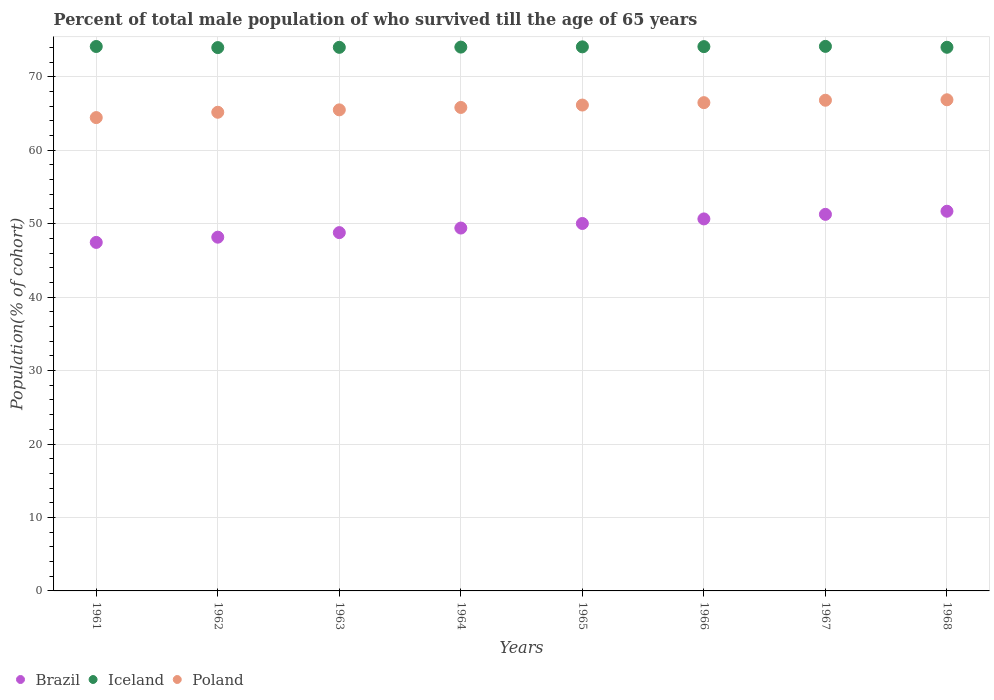What is the percentage of total male population who survived till the age of 65 years in Iceland in 1968?
Offer a very short reply. 74.02. Across all years, what is the maximum percentage of total male population who survived till the age of 65 years in Brazil?
Ensure brevity in your answer.  51.69. Across all years, what is the minimum percentage of total male population who survived till the age of 65 years in Poland?
Make the answer very short. 64.44. In which year was the percentage of total male population who survived till the age of 65 years in Iceland maximum?
Make the answer very short. 1967. In which year was the percentage of total male population who survived till the age of 65 years in Poland minimum?
Offer a very short reply. 1961. What is the total percentage of total male population who survived till the age of 65 years in Iceland in the graph?
Offer a terse response. 592.49. What is the difference between the percentage of total male population who survived till the age of 65 years in Poland in 1964 and that in 1965?
Your answer should be compact. -0.33. What is the difference between the percentage of total male population who survived till the age of 65 years in Brazil in 1965 and the percentage of total male population who survived till the age of 65 years in Iceland in 1963?
Provide a succinct answer. -23.98. What is the average percentage of total male population who survived till the age of 65 years in Iceland per year?
Offer a very short reply. 74.06. In the year 1967, what is the difference between the percentage of total male population who survived till the age of 65 years in Iceland and percentage of total male population who survived till the age of 65 years in Brazil?
Provide a short and direct response. 22.87. In how many years, is the percentage of total male population who survived till the age of 65 years in Poland greater than 4 %?
Keep it short and to the point. 8. What is the ratio of the percentage of total male population who survived till the age of 65 years in Iceland in 1966 to that in 1968?
Ensure brevity in your answer.  1. Is the percentage of total male population who survived till the age of 65 years in Iceland in 1961 less than that in 1968?
Your answer should be very brief. No. Is the difference between the percentage of total male population who survived till the age of 65 years in Iceland in 1963 and 1966 greater than the difference between the percentage of total male population who survived till the age of 65 years in Brazil in 1963 and 1966?
Give a very brief answer. Yes. What is the difference between the highest and the second highest percentage of total male population who survived till the age of 65 years in Brazil?
Give a very brief answer. 0.42. What is the difference between the highest and the lowest percentage of total male population who survived till the age of 65 years in Poland?
Offer a very short reply. 2.42. In how many years, is the percentage of total male population who survived till the age of 65 years in Poland greater than the average percentage of total male population who survived till the age of 65 years in Poland taken over all years?
Ensure brevity in your answer.  4. Is it the case that in every year, the sum of the percentage of total male population who survived till the age of 65 years in Brazil and percentage of total male population who survived till the age of 65 years in Poland  is greater than the percentage of total male population who survived till the age of 65 years in Iceland?
Your answer should be compact. Yes. Is the percentage of total male population who survived till the age of 65 years in Brazil strictly less than the percentage of total male population who survived till the age of 65 years in Poland over the years?
Keep it short and to the point. Yes. How many years are there in the graph?
Give a very brief answer. 8. Are the values on the major ticks of Y-axis written in scientific E-notation?
Give a very brief answer. No. How are the legend labels stacked?
Your answer should be compact. Horizontal. What is the title of the graph?
Your answer should be compact. Percent of total male population of who survived till the age of 65 years. What is the label or title of the Y-axis?
Ensure brevity in your answer.  Population(% of cohort). What is the Population(% of cohort) in Brazil in 1961?
Provide a short and direct response. 47.45. What is the Population(% of cohort) of Iceland in 1961?
Your answer should be very brief. 74.12. What is the Population(% of cohort) of Poland in 1961?
Keep it short and to the point. 64.44. What is the Population(% of cohort) in Brazil in 1962?
Your response must be concise. 48.16. What is the Population(% of cohort) in Iceland in 1962?
Your answer should be very brief. 73.98. What is the Population(% of cohort) in Poland in 1962?
Your answer should be very brief. 65.17. What is the Population(% of cohort) of Brazil in 1963?
Your answer should be very brief. 48.78. What is the Population(% of cohort) in Iceland in 1963?
Keep it short and to the point. 74.01. What is the Population(% of cohort) in Poland in 1963?
Offer a very short reply. 65.5. What is the Population(% of cohort) in Brazil in 1964?
Make the answer very short. 49.4. What is the Population(% of cohort) of Iceland in 1964?
Your response must be concise. 74.04. What is the Population(% of cohort) in Poland in 1964?
Your response must be concise. 65.82. What is the Population(% of cohort) of Brazil in 1965?
Provide a short and direct response. 50.03. What is the Population(% of cohort) in Iceland in 1965?
Offer a very short reply. 74.07. What is the Population(% of cohort) in Poland in 1965?
Provide a succinct answer. 66.15. What is the Population(% of cohort) in Brazil in 1966?
Provide a succinct answer. 50.65. What is the Population(% of cohort) in Iceland in 1966?
Give a very brief answer. 74.11. What is the Population(% of cohort) in Poland in 1966?
Make the answer very short. 66.48. What is the Population(% of cohort) of Brazil in 1967?
Your answer should be very brief. 51.27. What is the Population(% of cohort) in Iceland in 1967?
Your answer should be compact. 74.14. What is the Population(% of cohort) in Poland in 1967?
Make the answer very short. 66.81. What is the Population(% of cohort) of Brazil in 1968?
Your response must be concise. 51.69. What is the Population(% of cohort) of Iceland in 1968?
Provide a short and direct response. 74.02. What is the Population(% of cohort) of Poland in 1968?
Provide a short and direct response. 66.87. Across all years, what is the maximum Population(% of cohort) in Brazil?
Ensure brevity in your answer.  51.69. Across all years, what is the maximum Population(% of cohort) in Iceland?
Offer a terse response. 74.14. Across all years, what is the maximum Population(% of cohort) of Poland?
Offer a terse response. 66.87. Across all years, what is the minimum Population(% of cohort) in Brazil?
Offer a terse response. 47.45. Across all years, what is the minimum Population(% of cohort) in Iceland?
Offer a very short reply. 73.98. Across all years, what is the minimum Population(% of cohort) of Poland?
Your response must be concise. 64.44. What is the total Population(% of cohort) of Brazil in the graph?
Ensure brevity in your answer.  397.44. What is the total Population(% of cohort) in Iceland in the graph?
Make the answer very short. 592.49. What is the total Population(% of cohort) of Poland in the graph?
Your answer should be compact. 527.24. What is the difference between the Population(% of cohort) in Brazil in 1961 and that in 1962?
Provide a short and direct response. -0.71. What is the difference between the Population(% of cohort) of Iceland in 1961 and that in 1962?
Make the answer very short. 0.15. What is the difference between the Population(% of cohort) in Poland in 1961 and that in 1962?
Provide a succinct answer. -0.73. What is the difference between the Population(% of cohort) in Brazil in 1961 and that in 1963?
Your answer should be very brief. -1.33. What is the difference between the Population(% of cohort) in Iceland in 1961 and that in 1963?
Provide a succinct answer. 0.11. What is the difference between the Population(% of cohort) of Poland in 1961 and that in 1963?
Offer a terse response. -1.05. What is the difference between the Population(% of cohort) of Brazil in 1961 and that in 1964?
Give a very brief answer. -1.95. What is the difference between the Population(% of cohort) of Iceland in 1961 and that in 1964?
Ensure brevity in your answer.  0.08. What is the difference between the Population(% of cohort) in Poland in 1961 and that in 1964?
Make the answer very short. -1.38. What is the difference between the Population(% of cohort) of Brazil in 1961 and that in 1965?
Make the answer very short. -2.58. What is the difference between the Population(% of cohort) of Iceland in 1961 and that in 1965?
Provide a short and direct response. 0.05. What is the difference between the Population(% of cohort) of Poland in 1961 and that in 1965?
Keep it short and to the point. -1.71. What is the difference between the Population(% of cohort) of Brazil in 1961 and that in 1966?
Provide a short and direct response. -3.2. What is the difference between the Population(% of cohort) of Iceland in 1961 and that in 1966?
Provide a short and direct response. 0.02. What is the difference between the Population(% of cohort) of Poland in 1961 and that in 1966?
Offer a terse response. -2.03. What is the difference between the Population(% of cohort) in Brazil in 1961 and that in 1967?
Offer a very short reply. -3.82. What is the difference between the Population(% of cohort) in Iceland in 1961 and that in 1967?
Your answer should be very brief. -0.02. What is the difference between the Population(% of cohort) of Poland in 1961 and that in 1967?
Give a very brief answer. -2.36. What is the difference between the Population(% of cohort) of Brazil in 1961 and that in 1968?
Keep it short and to the point. -4.24. What is the difference between the Population(% of cohort) of Iceland in 1961 and that in 1968?
Ensure brevity in your answer.  0.11. What is the difference between the Population(% of cohort) of Poland in 1961 and that in 1968?
Your answer should be compact. -2.42. What is the difference between the Population(% of cohort) in Brazil in 1962 and that in 1963?
Provide a short and direct response. -0.62. What is the difference between the Population(% of cohort) in Iceland in 1962 and that in 1963?
Your answer should be compact. -0.03. What is the difference between the Population(% of cohort) of Poland in 1962 and that in 1963?
Offer a very short reply. -0.33. What is the difference between the Population(% of cohort) in Brazil in 1962 and that in 1964?
Your answer should be compact. -1.24. What is the difference between the Population(% of cohort) in Iceland in 1962 and that in 1964?
Make the answer very short. -0.07. What is the difference between the Population(% of cohort) in Poland in 1962 and that in 1964?
Offer a terse response. -0.65. What is the difference between the Population(% of cohort) in Brazil in 1962 and that in 1965?
Your response must be concise. -1.86. What is the difference between the Population(% of cohort) in Iceland in 1962 and that in 1965?
Keep it short and to the point. -0.1. What is the difference between the Population(% of cohort) in Poland in 1962 and that in 1965?
Your answer should be compact. -0.98. What is the difference between the Population(% of cohort) of Brazil in 1962 and that in 1966?
Ensure brevity in your answer.  -2.49. What is the difference between the Population(% of cohort) of Iceland in 1962 and that in 1966?
Your answer should be compact. -0.13. What is the difference between the Population(% of cohort) of Poland in 1962 and that in 1966?
Provide a short and direct response. -1.31. What is the difference between the Population(% of cohort) in Brazil in 1962 and that in 1967?
Your answer should be compact. -3.11. What is the difference between the Population(% of cohort) of Iceland in 1962 and that in 1967?
Give a very brief answer. -0.16. What is the difference between the Population(% of cohort) of Poland in 1962 and that in 1967?
Offer a terse response. -1.64. What is the difference between the Population(% of cohort) in Brazil in 1962 and that in 1968?
Make the answer very short. -3.53. What is the difference between the Population(% of cohort) in Iceland in 1962 and that in 1968?
Give a very brief answer. -0.04. What is the difference between the Population(% of cohort) in Poland in 1962 and that in 1968?
Keep it short and to the point. -1.7. What is the difference between the Population(% of cohort) of Brazil in 1963 and that in 1964?
Offer a terse response. -0.62. What is the difference between the Population(% of cohort) in Iceland in 1963 and that in 1964?
Give a very brief answer. -0.03. What is the difference between the Population(% of cohort) in Poland in 1963 and that in 1964?
Your response must be concise. -0.33. What is the difference between the Population(% of cohort) of Brazil in 1963 and that in 1965?
Ensure brevity in your answer.  -1.24. What is the difference between the Population(% of cohort) of Iceland in 1963 and that in 1965?
Provide a succinct answer. -0.07. What is the difference between the Population(% of cohort) of Poland in 1963 and that in 1965?
Provide a succinct answer. -0.65. What is the difference between the Population(% of cohort) of Brazil in 1963 and that in 1966?
Your answer should be very brief. -1.86. What is the difference between the Population(% of cohort) of Iceland in 1963 and that in 1966?
Offer a terse response. -0.1. What is the difference between the Population(% of cohort) of Poland in 1963 and that in 1966?
Offer a very short reply. -0.98. What is the difference between the Population(% of cohort) of Brazil in 1963 and that in 1967?
Your response must be concise. -2.49. What is the difference between the Population(% of cohort) in Iceland in 1963 and that in 1967?
Offer a very short reply. -0.13. What is the difference between the Population(% of cohort) in Poland in 1963 and that in 1967?
Offer a terse response. -1.31. What is the difference between the Population(% of cohort) in Brazil in 1963 and that in 1968?
Make the answer very short. -2.91. What is the difference between the Population(% of cohort) in Iceland in 1963 and that in 1968?
Make the answer very short. -0.01. What is the difference between the Population(% of cohort) of Poland in 1963 and that in 1968?
Offer a terse response. -1.37. What is the difference between the Population(% of cohort) of Brazil in 1964 and that in 1965?
Your response must be concise. -0.62. What is the difference between the Population(% of cohort) in Iceland in 1964 and that in 1965?
Provide a succinct answer. -0.03. What is the difference between the Population(% of cohort) of Poland in 1964 and that in 1965?
Keep it short and to the point. -0.33. What is the difference between the Population(% of cohort) of Brazil in 1964 and that in 1966?
Provide a short and direct response. -1.24. What is the difference between the Population(% of cohort) of Iceland in 1964 and that in 1966?
Provide a short and direct response. -0.07. What is the difference between the Population(% of cohort) in Poland in 1964 and that in 1966?
Give a very brief answer. -0.65. What is the difference between the Population(% of cohort) in Brazil in 1964 and that in 1967?
Your answer should be compact. -1.86. What is the difference between the Population(% of cohort) of Iceland in 1964 and that in 1967?
Your answer should be very brief. -0.1. What is the difference between the Population(% of cohort) of Poland in 1964 and that in 1967?
Your answer should be very brief. -0.98. What is the difference between the Population(% of cohort) in Brazil in 1964 and that in 1968?
Offer a terse response. -2.29. What is the difference between the Population(% of cohort) in Iceland in 1964 and that in 1968?
Your answer should be very brief. 0.02. What is the difference between the Population(% of cohort) in Poland in 1964 and that in 1968?
Provide a succinct answer. -1.04. What is the difference between the Population(% of cohort) of Brazil in 1965 and that in 1966?
Provide a succinct answer. -0.62. What is the difference between the Population(% of cohort) in Iceland in 1965 and that in 1966?
Your answer should be compact. -0.03. What is the difference between the Population(% of cohort) in Poland in 1965 and that in 1966?
Ensure brevity in your answer.  -0.33. What is the difference between the Population(% of cohort) of Brazil in 1965 and that in 1967?
Keep it short and to the point. -1.24. What is the difference between the Population(% of cohort) of Iceland in 1965 and that in 1967?
Your response must be concise. -0.07. What is the difference between the Population(% of cohort) in Poland in 1965 and that in 1967?
Provide a succinct answer. -0.65. What is the difference between the Population(% of cohort) in Brazil in 1965 and that in 1968?
Make the answer very short. -1.67. What is the difference between the Population(% of cohort) of Iceland in 1965 and that in 1968?
Offer a terse response. 0.06. What is the difference between the Population(% of cohort) in Poland in 1965 and that in 1968?
Your answer should be compact. -0.72. What is the difference between the Population(% of cohort) of Brazil in 1966 and that in 1967?
Your answer should be very brief. -0.62. What is the difference between the Population(% of cohort) in Iceland in 1966 and that in 1967?
Your answer should be compact. -0.03. What is the difference between the Population(% of cohort) in Poland in 1966 and that in 1967?
Keep it short and to the point. -0.33. What is the difference between the Population(% of cohort) of Brazil in 1966 and that in 1968?
Your answer should be very brief. -1.05. What is the difference between the Population(% of cohort) of Iceland in 1966 and that in 1968?
Give a very brief answer. 0.09. What is the difference between the Population(% of cohort) in Poland in 1966 and that in 1968?
Keep it short and to the point. -0.39. What is the difference between the Population(% of cohort) in Brazil in 1967 and that in 1968?
Provide a short and direct response. -0.42. What is the difference between the Population(% of cohort) in Iceland in 1967 and that in 1968?
Give a very brief answer. 0.12. What is the difference between the Population(% of cohort) in Poland in 1967 and that in 1968?
Offer a terse response. -0.06. What is the difference between the Population(% of cohort) in Brazil in 1961 and the Population(% of cohort) in Iceland in 1962?
Your response must be concise. -26.53. What is the difference between the Population(% of cohort) of Brazil in 1961 and the Population(% of cohort) of Poland in 1962?
Your response must be concise. -17.72. What is the difference between the Population(% of cohort) of Iceland in 1961 and the Population(% of cohort) of Poland in 1962?
Your response must be concise. 8.95. What is the difference between the Population(% of cohort) of Brazil in 1961 and the Population(% of cohort) of Iceland in 1963?
Provide a short and direct response. -26.56. What is the difference between the Population(% of cohort) of Brazil in 1961 and the Population(% of cohort) of Poland in 1963?
Offer a very short reply. -18.05. What is the difference between the Population(% of cohort) in Iceland in 1961 and the Population(% of cohort) in Poland in 1963?
Offer a terse response. 8.63. What is the difference between the Population(% of cohort) of Brazil in 1961 and the Population(% of cohort) of Iceland in 1964?
Ensure brevity in your answer.  -26.59. What is the difference between the Population(% of cohort) of Brazil in 1961 and the Population(% of cohort) of Poland in 1964?
Keep it short and to the point. -18.37. What is the difference between the Population(% of cohort) of Iceland in 1961 and the Population(% of cohort) of Poland in 1964?
Offer a terse response. 8.3. What is the difference between the Population(% of cohort) in Brazil in 1961 and the Population(% of cohort) in Iceland in 1965?
Keep it short and to the point. -26.62. What is the difference between the Population(% of cohort) in Brazil in 1961 and the Population(% of cohort) in Poland in 1965?
Keep it short and to the point. -18.7. What is the difference between the Population(% of cohort) in Iceland in 1961 and the Population(% of cohort) in Poland in 1965?
Your response must be concise. 7.97. What is the difference between the Population(% of cohort) in Brazil in 1961 and the Population(% of cohort) in Iceland in 1966?
Provide a short and direct response. -26.66. What is the difference between the Population(% of cohort) in Brazil in 1961 and the Population(% of cohort) in Poland in 1966?
Provide a short and direct response. -19.03. What is the difference between the Population(% of cohort) in Iceland in 1961 and the Population(% of cohort) in Poland in 1966?
Keep it short and to the point. 7.64. What is the difference between the Population(% of cohort) in Brazil in 1961 and the Population(% of cohort) in Iceland in 1967?
Give a very brief answer. -26.69. What is the difference between the Population(% of cohort) of Brazil in 1961 and the Population(% of cohort) of Poland in 1967?
Ensure brevity in your answer.  -19.36. What is the difference between the Population(% of cohort) in Iceland in 1961 and the Population(% of cohort) in Poland in 1967?
Offer a terse response. 7.32. What is the difference between the Population(% of cohort) of Brazil in 1961 and the Population(% of cohort) of Iceland in 1968?
Offer a terse response. -26.57. What is the difference between the Population(% of cohort) of Brazil in 1961 and the Population(% of cohort) of Poland in 1968?
Offer a terse response. -19.42. What is the difference between the Population(% of cohort) in Iceland in 1961 and the Population(% of cohort) in Poland in 1968?
Ensure brevity in your answer.  7.25. What is the difference between the Population(% of cohort) of Brazil in 1962 and the Population(% of cohort) of Iceland in 1963?
Your answer should be very brief. -25.85. What is the difference between the Population(% of cohort) of Brazil in 1962 and the Population(% of cohort) of Poland in 1963?
Your answer should be very brief. -17.34. What is the difference between the Population(% of cohort) in Iceland in 1962 and the Population(% of cohort) in Poland in 1963?
Keep it short and to the point. 8.48. What is the difference between the Population(% of cohort) in Brazil in 1962 and the Population(% of cohort) in Iceland in 1964?
Your answer should be compact. -25.88. What is the difference between the Population(% of cohort) in Brazil in 1962 and the Population(% of cohort) in Poland in 1964?
Make the answer very short. -17.66. What is the difference between the Population(% of cohort) in Iceland in 1962 and the Population(% of cohort) in Poland in 1964?
Offer a terse response. 8.15. What is the difference between the Population(% of cohort) of Brazil in 1962 and the Population(% of cohort) of Iceland in 1965?
Your response must be concise. -25.91. What is the difference between the Population(% of cohort) in Brazil in 1962 and the Population(% of cohort) in Poland in 1965?
Your answer should be compact. -17.99. What is the difference between the Population(% of cohort) in Iceland in 1962 and the Population(% of cohort) in Poland in 1965?
Your answer should be very brief. 7.82. What is the difference between the Population(% of cohort) in Brazil in 1962 and the Population(% of cohort) in Iceland in 1966?
Offer a terse response. -25.95. What is the difference between the Population(% of cohort) of Brazil in 1962 and the Population(% of cohort) of Poland in 1966?
Ensure brevity in your answer.  -18.32. What is the difference between the Population(% of cohort) of Iceland in 1962 and the Population(% of cohort) of Poland in 1966?
Your response must be concise. 7.5. What is the difference between the Population(% of cohort) of Brazil in 1962 and the Population(% of cohort) of Iceland in 1967?
Offer a terse response. -25.98. What is the difference between the Population(% of cohort) of Brazil in 1962 and the Population(% of cohort) of Poland in 1967?
Keep it short and to the point. -18.64. What is the difference between the Population(% of cohort) in Iceland in 1962 and the Population(% of cohort) in Poland in 1967?
Keep it short and to the point. 7.17. What is the difference between the Population(% of cohort) of Brazil in 1962 and the Population(% of cohort) of Iceland in 1968?
Provide a succinct answer. -25.86. What is the difference between the Population(% of cohort) in Brazil in 1962 and the Population(% of cohort) in Poland in 1968?
Offer a very short reply. -18.71. What is the difference between the Population(% of cohort) in Iceland in 1962 and the Population(% of cohort) in Poland in 1968?
Offer a terse response. 7.11. What is the difference between the Population(% of cohort) of Brazil in 1963 and the Population(% of cohort) of Iceland in 1964?
Ensure brevity in your answer.  -25.26. What is the difference between the Population(% of cohort) in Brazil in 1963 and the Population(% of cohort) in Poland in 1964?
Make the answer very short. -17.04. What is the difference between the Population(% of cohort) in Iceland in 1963 and the Population(% of cohort) in Poland in 1964?
Offer a very short reply. 8.18. What is the difference between the Population(% of cohort) in Brazil in 1963 and the Population(% of cohort) in Iceland in 1965?
Provide a short and direct response. -25.29. What is the difference between the Population(% of cohort) in Brazil in 1963 and the Population(% of cohort) in Poland in 1965?
Your answer should be very brief. -17.37. What is the difference between the Population(% of cohort) in Iceland in 1963 and the Population(% of cohort) in Poland in 1965?
Give a very brief answer. 7.86. What is the difference between the Population(% of cohort) in Brazil in 1963 and the Population(% of cohort) in Iceland in 1966?
Make the answer very short. -25.32. What is the difference between the Population(% of cohort) of Brazil in 1963 and the Population(% of cohort) of Poland in 1966?
Your answer should be compact. -17.7. What is the difference between the Population(% of cohort) of Iceland in 1963 and the Population(% of cohort) of Poland in 1966?
Provide a succinct answer. 7.53. What is the difference between the Population(% of cohort) of Brazil in 1963 and the Population(% of cohort) of Iceland in 1967?
Provide a short and direct response. -25.36. What is the difference between the Population(% of cohort) of Brazil in 1963 and the Population(% of cohort) of Poland in 1967?
Offer a terse response. -18.02. What is the difference between the Population(% of cohort) in Iceland in 1963 and the Population(% of cohort) in Poland in 1967?
Give a very brief answer. 7.2. What is the difference between the Population(% of cohort) of Brazil in 1963 and the Population(% of cohort) of Iceland in 1968?
Your answer should be compact. -25.23. What is the difference between the Population(% of cohort) of Brazil in 1963 and the Population(% of cohort) of Poland in 1968?
Offer a terse response. -18.09. What is the difference between the Population(% of cohort) of Iceland in 1963 and the Population(% of cohort) of Poland in 1968?
Keep it short and to the point. 7.14. What is the difference between the Population(% of cohort) in Brazil in 1964 and the Population(% of cohort) in Iceland in 1965?
Provide a short and direct response. -24.67. What is the difference between the Population(% of cohort) in Brazil in 1964 and the Population(% of cohort) in Poland in 1965?
Your answer should be compact. -16.75. What is the difference between the Population(% of cohort) of Iceland in 1964 and the Population(% of cohort) of Poland in 1965?
Offer a terse response. 7.89. What is the difference between the Population(% of cohort) in Brazil in 1964 and the Population(% of cohort) in Iceland in 1966?
Keep it short and to the point. -24.7. What is the difference between the Population(% of cohort) of Brazil in 1964 and the Population(% of cohort) of Poland in 1966?
Provide a succinct answer. -17.07. What is the difference between the Population(% of cohort) of Iceland in 1964 and the Population(% of cohort) of Poland in 1966?
Your answer should be compact. 7.56. What is the difference between the Population(% of cohort) in Brazil in 1964 and the Population(% of cohort) in Iceland in 1967?
Make the answer very short. -24.74. What is the difference between the Population(% of cohort) of Brazil in 1964 and the Population(% of cohort) of Poland in 1967?
Provide a short and direct response. -17.4. What is the difference between the Population(% of cohort) of Iceland in 1964 and the Population(% of cohort) of Poland in 1967?
Your answer should be compact. 7.24. What is the difference between the Population(% of cohort) of Brazil in 1964 and the Population(% of cohort) of Iceland in 1968?
Your response must be concise. -24.61. What is the difference between the Population(% of cohort) in Brazil in 1964 and the Population(% of cohort) in Poland in 1968?
Offer a very short reply. -17.46. What is the difference between the Population(% of cohort) of Iceland in 1964 and the Population(% of cohort) of Poland in 1968?
Your response must be concise. 7.17. What is the difference between the Population(% of cohort) in Brazil in 1965 and the Population(% of cohort) in Iceland in 1966?
Give a very brief answer. -24.08. What is the difference between the Population(% of cohort) in Brazil in 1965 and the Population(% of cohort) in Poland in 1966?
Keep it short and to the point. -16.45. What is the difference between the Population(% of cohort) of Iceland in 1965 and the Population(% of cohort) of Poland in 1966?
Make the answer very short. 7.6. What is the difference between the Population(% of cohort) in Brazil in 1965 and the Population(% of cohort) in Iceland in 1967?
Offer a very short reply. -24.11. What is the difference between the Population(% of cohort) of Brazil in 1965 and the Population(% of cohort) of Poland in 1967?
Provide a succinct answer. -16.78. What is the difference between the Population(% of cohort) of Iceland in 1965 and the Population(% of cohort) of Poland in 1967?
Offer a terse response. 7.27. What is the difference between the Population(% of cohort) in Brazil in 1965 and the Population(% of cohort) in Iceland in 1968?
Your answer should be compact. -23.99. What is the difference between the Population(% of cohort) in Brazil in 1965 and the Population(% of cohort) in Poland in 1968?
Offer a terse response. -16.84. What is the difference between the Population(% of cohort) in Iceland in 1965 and the Population(% of cohort) in Poland in 1968?
Your answer should be very brief. 7.21. What is the difference between the Population(% of cohort) in Brazil in 1966 and the Population(% of cohort) in Iceland in 1967?
Keep it short and to the point. -23.49. What is the difference between the Population(% of cohort) of Brazil in 1966 and the Population(% of cohort) of Poland in 1967?
Your response must be concise. -16.16. What is the difference between the Population(% of cohort) of Iceland in 1966 and the Population(% of cohort) of Poland in 1967?
Keep it short and to the point. 7.3. What is the difference between the Population(% of cohort) of Brazil in 1966 and the Population(% of cohort) of Iceland in 1968?
Provide a succinct answer. -23.37. What is the difference between the Population(% of cohort) of Brazil in 1966 and the Population(% of cohort) of Poland in 1968?
Provide a succinct answer. -16.22. What is the difference between the Population(% of cohort) in Iceland in 1966 and the Population(% of cohort) in Poland in 1968?
Offer a very short reply. 7.24. What is the difference between the Population(% of cohort) of Brazil in 1967 and the Population(% of cohort) of Iceland in 1968?
Provide a succinct answer. -22.75. What is the difference between the Population(% of cohort) in Brazil in 1967 and the Population(% of cohort) in Poland in 1968?
Your answer should be compact. -15.6. What is the difference between the Population(% of cohort) of Iceland in 1967 and the Population(% of cohort) of Poland in 1968?
Give a very brief answer. 7.27. What is the average Population(% of cohort) in Brazil per year?
Your response must be concise. 49.68. What is the average Population(% of cohort) in Iceland per year?
Make the answer very short. 74.06. What is the average Population(% of cohort) in Poland per year?
Your answer should be compact. 65.91. In the year 1961, what is the difference between the Population(% of cohort) in Brazil and Population(% of cohort) in Iceland?
Give a very brief answer. -26.67. In the year 1961, what is the difference between the Population(% of cohort) of Brazil and Population(% of cohort) of Poland?
Your answer should be compact. -16.99. In the year 1961, what is the difference between the Population(% of cohort) in Iceland and Population(% of cohort) in Poland?
Keep it short and to the point. 9.68. In the year 1962, what is the difference between the Population(% of cohort) in Brazil and Population(% of cohort) in Iceland?
Provide a succinct answer. -25.81. In the year 1962, what is the difference between the Population(% of cohort) of Brazil and Population(% of cohort) of Poland?
Make the answer very short. -17.01. In the year 1962, what is the difference between the Population(% of cohort) of Iceland and Population(% of cohort) of Poland?
Offer a terse response. 8.81. In the year 1963, what is the difference between the Population(% of cohort) in Brazil and Population(% of cohort) in Iceland?
Provide a short and direct response. -25.23. In the year 1963, what is the difference between the Population(% of cohort) in Brazil and Population(% of cohort) in Poland?
Provide a short and direct response. -16.71. In the year 1963, what is the difference between the Population(% of cohort) in Iceland and Population(% of cohort) in Poland?
Make the answer very short. 8.51. In the year 1964, what is the difference between the Population(% of cohort) in Brazil and Population(% of cohort) in Iceland?
Provide a short and direct response. -24.64. In the year 1964, what is the difference between the Population(% of cohort) in Brazil and Population(% of cohort) in Poland?
Provide a short and direct response. -16.42. In the year 1964, what is the difference between the Population(% of cohort) of Iceland and Population(% of cohort) of Poland?
Provide a short and direct response. 8.22. In the year 1965, what is the difference between the Population(% of cohort) in Brazil and Population(% of cohort) in Iceland?
Ensure brevity in your answer.  -24.05. In the year 1965, what is the difference between the Population(% of cohort) in Brazil and Population(% of cohort) in Poland?
Provide a short and direct response. -16.13. In the year 1965, what is the difference between the Population(% of cohort) in Iceland and Population(% of cohort) in Poland?
Offer a terse response. 7.92. In the year 1966, what is the difference between the Population(% of cohort) in Brazil and Population(% of cohort) in Iceland?
Make the answer very short. -23.46. In the year 1966, what is the difference between the Population(% of cohort) of Brazil and Population(% of cohort) of Poland?
Your answer should be compact. -15.83. In the year 1966, what is the difference between the Population(% of cohort) of Iceland and Population(% of cohort) of Poland?
Offer a terse response. 7.63. In the year 1967, what is the difference between the Population(% of cohort) of Brazil and Population(% of cohort) of Iceland?
Provide a succinct answer. -22.87. In the year 1967, what is the difference between the Population(% of cohort) in Brazil and Population(% of cohort) in Poland?
Your answer should be compact. -15.54. In the year 1967, what is the difference between the Population(% of cohort) of Iceland and Population(% of cohort) of Poland?
Keep it short and to the point. 7.33. In the year 1968, what is the difference between the Population(% of cohort) of Brazil and Population(% of cohort) of Iceland?
Ensure brevity in your answer.  -22.32. In the year 1968, what is the difference between the Population(% of cohort) in Brazil and Population(% of cohort) in Poland?
Ensure brevity in your answer.  -15.17. In the year 1968, what is the difference between the Population(% of cohort) of Iceland and Population(% of cohort) of Poland?
Offer a terse response. 7.15. What is the ratio of the Population(% of cohort) of Brazil in 1961 to that in 1962?
Ensure brevity in your answer.  0.99. What is the ratio of the Population(% of cohort) in Poland in 1961 to that in 1962?
Make the answer very short. 0.99. What is the ratio of the Population(% of cohort) in Brazil in 1961 to that in 1963?
Provide a short and direct response. 0.97. What is the ratio of the Population(% of cohort) of Poland in 1961 to that in 1963?
Your response must be concise. 0.98. What is the ratio of the Population(% of cohort) of Brazil in 1961 to that in 1964?
Keep it short and to the point. 0.96. What is the ratio of the Population(% of cohort) in Iceland in 1961 to that in 1964?
Your answer should be compact. 1. What is the ratio of the Population(% of cohort) of Brazil in 1961 to that in 1965?
Your answer should be very brief. 0.95. What is the ratio of the Population(% of cohort) of Iceland in 1961 to that in 1965?
Give a very brief answer. 1. What is the ratio of the Population(% of cohort) in Poland in 1961 to that in 1965?
Your answer should be compact. 0.97. What is the ratio of the Population(% of cohort) of Brazil in 1961 to that in 1966?
Offer a very short reply. 0.94. What is the ratio of the Population(% of cohort) of Iceland in 1961 to that in 1966?
Offer a terse response. 1. What is the ratio of the Population(% of cohort) of Poland in 1961 to that in 1966?
Make the answer very short. 0.97. What is the ratio of the Population(% of cohort) of Brazil in 1961 to that in 1967?
Keep it short and to the point. 0.93. What is the ratio of the Population(% of cohort) of Iceland in 1961 to that in 1967?
Offer a terse response. 1. What is the ratio of the Population(% of cohort) of Poland in 1961 to that in 1967?
Keep it short and to the point. 0.96. What is the ratio of the Population(% of cohort) of Brazil in 1961 to that in 1968?
Provide a succinct answer. 0.92. What is the ratio of the Population(% of cohort) in Poland in 1961 to that in 1968?
Ensure brevity in your answer.  0.96. What is the ratio of the Population(% of cohort) in Brazil in 1962 to that in 1963?
Provide a succinct answer. 0.99. What is the ratio of the Population(% of cohort) in Iceland in 1962 to that in 1963?
Provide a succinct answer. 1. What is the ratio of the Population(% of cohort) of Brazil in 1962 to that in 1964?
Provide a short and direct response. 0.97. What is the ratio of the Population(% of cohort) in Brazil in 1962 to that in 1965?
Your answer should be compact. 0.96. What is the ratio of the Population(% of cohort) of Poland in 1962 to that in 1965?
Your response must be concise. 0.99. What is the ratio of the Population(% of cohort) of Brazil in 1962 to that in 1966?
Provide a short and direct response. 0.95. What is the ratio of the Population(% of cohort) of Poland in 1962 to that in 1966?
Provide a short and direct response. 0.98. What is the ratio of the Population(% of cohort) in Brazil in 1962 to that in 1967?
Offer a very short reply. 0.94. What is the ratio of the Population(% of cohort) of Poland in 1962 to that in 1967?
Provide a succinct answer. 0.98. What is the ratio of the Population(% of cohort) in Brazil in 1962 to that in 1968?
Your answer should be compact. 0.93. What is the ratio of the Population(% of cohort) of Iceland in 1962 to that in 1968?
Your answer should be very brief. 1. What is the ratio of the Population(% of cohort) of Poland in 1962 to that in 1968?
Your response must be concise. 0.97. What is the ratio of the Population(% of cohort) of Brazil in 1963 to that in 1964?
Your response must be concise. 0.99. What is the ratio of the Population(% of cohort) of Brazil in 1963 to that in 1965?
Your answer should be very brief. 0.98. What is the ratio of the Population(% of cohort) in Iceland in 1963 to that in 1965?
Provide a succinct answer. 1. What is the ratio of the Population(% of cohort) in Poland in 1963 to that in 1965?
Make the answer very short. 0.99. What is the ratio of the Population(% of cohort) of Brazil in 1963 to that in 1966?
Your answer should be compact. 0.96. What is the ratio of the Population(% of cohort) in Iceland in 1963 to that in 1966?
Make the answer very short. 1. What is the ratio of the Population(% of cohort) of Poland in 1963 to that in 1966?
Ensure brevity in your answer.  0.99. What is the ratio of the Population(% of cohort) of Brazil in 1963 to that in 1967?
Your answer should be compact. 0.95. What is the ratio of the Population(% of cohort) of Poland in 1963 to that in 1967?
Offer a terse response. 0.98. What is the ratio of the Population(% of cohort) of Brazil in 1963 to that in 1968?
Offer a terse response. 0.94. What is the ratio of the Population(% of cohort) of Iceland in 1963 to that in 1968?
Offer a very short reply. 1. What is the ratio of the Population(% of cohort) in Poland in 1963 to that in 1968?
Provide a short and direct response. 0.98. What is the ratio of the Population(% of cohort) of Brazil in 1964 to that in 1965?
Offer a very short reply. 0.99. What is the ratio of the Population(% of cohort) of Iceland in 1964 to that in 1965?
Keep it short and to the point. 1. What is the ratio of the Population(% of cohort) of Poland in 1964 to that in 1965?
Your answer should be very brief. 1. What is the ratio of the Population(% of cohort) of Brazil in 1964 to that in 1966?
Provide a short and direct response. 0.98. What is the ratio of the Population(% of cohort) in Iceland in 1964 to that in 1966?
Provide a short and direct response. 1. What is the ratio of the Population(% of cohort) in Poland in 1964 to that in 1966?
Your answer should be very brief. 0.99. What is the ratio of the Population(% of cohort) of Brazil in 1964 to that in 1967?
Provide a short and direct response. 0.96. What is the ratio of the Population(% of cohort) of Iceland in 1964 to that in 1967?
Make the answer very short. 1. What is the ratio of the Population(% of cohort) in Poland in 1964 to that in 1967?
Offer a terse response. 0.99. What is the ratio of the Population(% of cohort) in Brazil in 1964 to that in 1968?
Ensure brevity in your answer.  0.96. What is the ratio of the Population(% of cohort) in Iceland in 1964 to that in 1968?
Your answer should be very brief. 1. What is the ratio of the Population(% of cohort) in Poland in 1964 to that in 1968?
Your answer should be very brief. 0.98. What is the ratio of the Population(% of cohort) in Brazil in 1965 to that in 1966?
Your answer should be compact. 0.99. What is the ratio of the Population(% of cohort) of Poland in 1965 to that in 1966?
Keep it short and to the point. 1. What is the ratio of the Population(% of cohort) of Brazil in 1965 to that in 1967?
Your response must be concise. 0.98. What is the ratio of the Population(% of cohort) in Poland in 1965 to that in 1967?
Provide a short and direct response. 0.99. What is the ratio of the Population(% of cohort) of Iceland in 1965 to that in 1968?
Your answer should be very brief. 1. What is the ratio of the Population(% of cohort) of Poland in 1965 to that in 1968?
Offer a terse response. 0.99. What is the ratio of the Population(% of cohort) in Brazil in 1966 to that in 1967?
Your response must be concise. 0.99. What is the ratio of the Population(% of cohort) in Iceland in 1966 to that in 1967?
Provide a succinct answer. 1. What is the ratio of the Population(% of cohort) in Brazil in 1966 to that in 1968?
Ensure brevity in your answer.  0.98. What is the ratio of the Population(% of cohort) of Iceland in 1966 to that in 1968?
Provide a succinct answer. 1. What is the ratio of the Population(% of cohort) in Poland in 1966 to that in 1968?
Ensure brevity in your answer.  0.99. What is the difference between the highest and the second highest Population(% of cohort) in Brazil?
Your answer should be very brief. 0.42. What is the difference between the highest and the second highest Population(% of cohort) of Iceland?
Offer a terse response. 0.02. What is the difference between the highest and the second highest Population(% of cohort) in Poland?
Offer a very short reply. 0.06. What is the difference between the highest and the lowest Population(% of cohort) in Brazil?
Keep it short and to the point. 4.24. What is the difference between the highest and the lowest Population(% of cohort) of Iceland?
Offer a terse response. 0.16. What is the difference between the highest and the lowest Population(% of cohort) in Poland?
Ensure brevity in your answer.  2.42. 